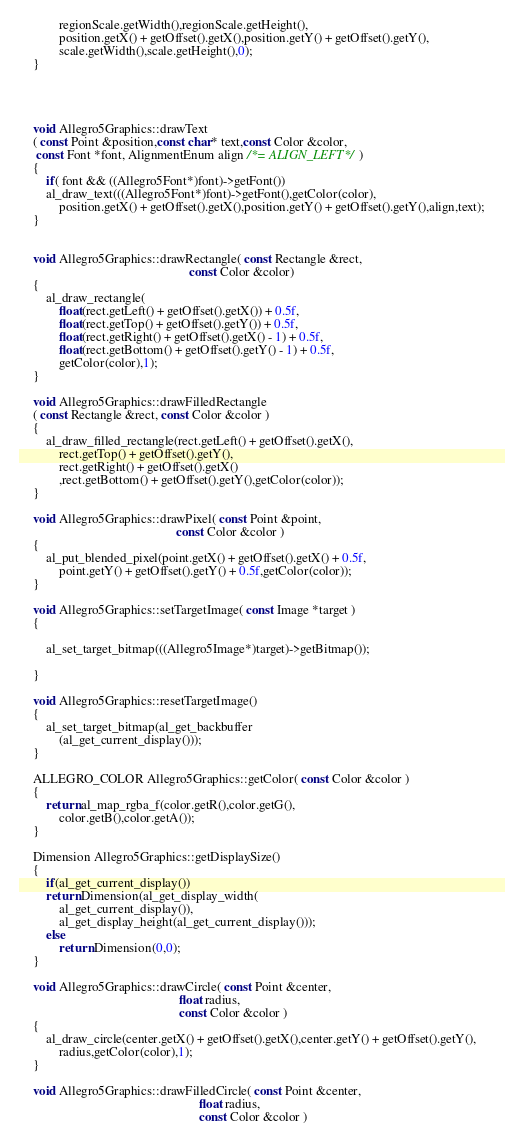Convert code to text. <code><loc_0><loc_0><loc_500><loc_500><_C++_>			regionScale.getWidth(),regionScale.getHeight(),
			position.getX() + getOffset().getX(),position.getY() + getOffset().getY(),
			scale.getWidth(),scale.getHeight(),0);
	}




	void Allegro5Graphics::drawText
	( const Point &position,const char* text,const Color &color, 
	 const Font *font, AlignmentEnum align /*= ALIGN_LEFT*/ )
	{
		if( font && ((Allegro5Font*)font)->getFont())
		al_draw_text(((Allegro5Font*)font)->getFont(),getColor(color),
			position.getX() + getOffset().getX(),position.getY() + getOffset().getY(),align,text);
	}


	void Allegro5Graphics::drawRectangle( const Rectangle &rect, 
													const Color &color)
	{
		al_draw_rectangle(
			float(rect.getLeft() + getOffset().getX()) + 0.5f,
			float(rect.getTop() + getOffset().getY()) + 0.5f,
			float(rect.getRight() + getOffset().getX() - 1) + 0.5f,
			float(rect.getBottom() + getOffset().getY() - 1) + 0.5f,
			getColor(color),1);
	}

	void Allegro5Graphics::drawFilledRectangle
	( const Rectangle &rect, const Color &color )
	{
		al_draw_filled_rectangle(rect.getLeft() + getOffset().getX(),
			rect.getTop() + getOffset().getY(),
			rect.getRight() + getOffset().getX()
			,rect.getBottom() + getOffset().getY(),getColor(color));
	}

	void Allegro5Graphics::drawPixel( const Point &point,
												const Color &color )
	{
		al_put_blended_pixel(point.getX() + getOffset().getX() + 0.5f,
			point.getY() + getOffset().getY() + 0.5f,getColor(color));
	}

	void Allegro5Graphics::setTargetImage( const Image *target )
	{

		al_set_target_bitmap(((Allegro5Image*)target)->getBitmap());

	}

	void Allegro5Graphics::resetTargetImage()
	{
		al_set_target_bitmap(al_get_backbuffer
			(al_get_current_display()));
	}

	ALLEGRO_COLOR Allegro5Graphics::getColor( const Color &color )
	{
		return al_map_rgba_f(color.getR(),color.getG(),
			color.getB(),color.getA());
	}

	Dimension Allegro5Graphics::getDisplaySize()
	{
		if(al_get_current_display())
		return Dimension(al_get_display_width(
			al_get_current_display()),
			al_get_display_height(al_get_current_display()));
		else
			return Dimension(0,0);
	}

	void Allegro5Graphics::drawCircle( const Point &center,
												 float radius, 
												 const Color &color )
	{
		al_draw_circle(center.getX() + getOffset().getX(),center.getY() + getOffset().getY(),
			radius,getColor(color),1);
	}

	void Allegro5Graphics::drawFilledCircle( const Point &center,
													   float radius,
													   const Color &color )</code> 